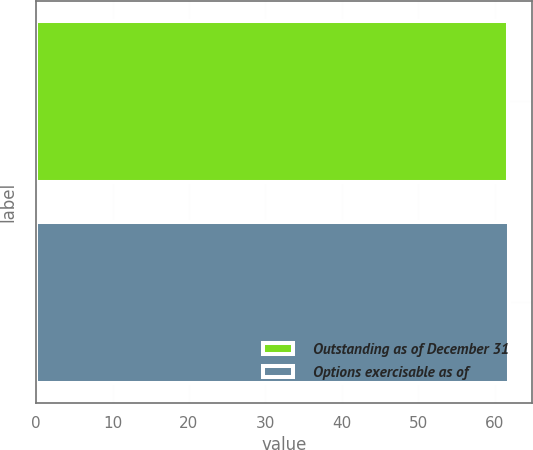Convert chart. <chart><loc_0><loc_0><loc_500><loc_500><bar_chart><fcel>Outstanding as of December 31<fcel>Options exercisable as of<nl><fcel>61.7<fcel>61.8<nl></chart> 